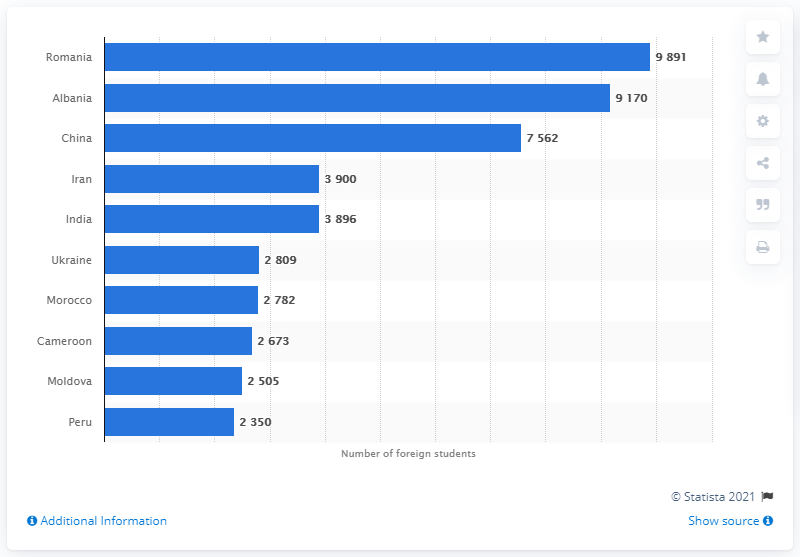Give some essential details in this illustration. The largest group of foreign students in the country was represented by students from Romania. 